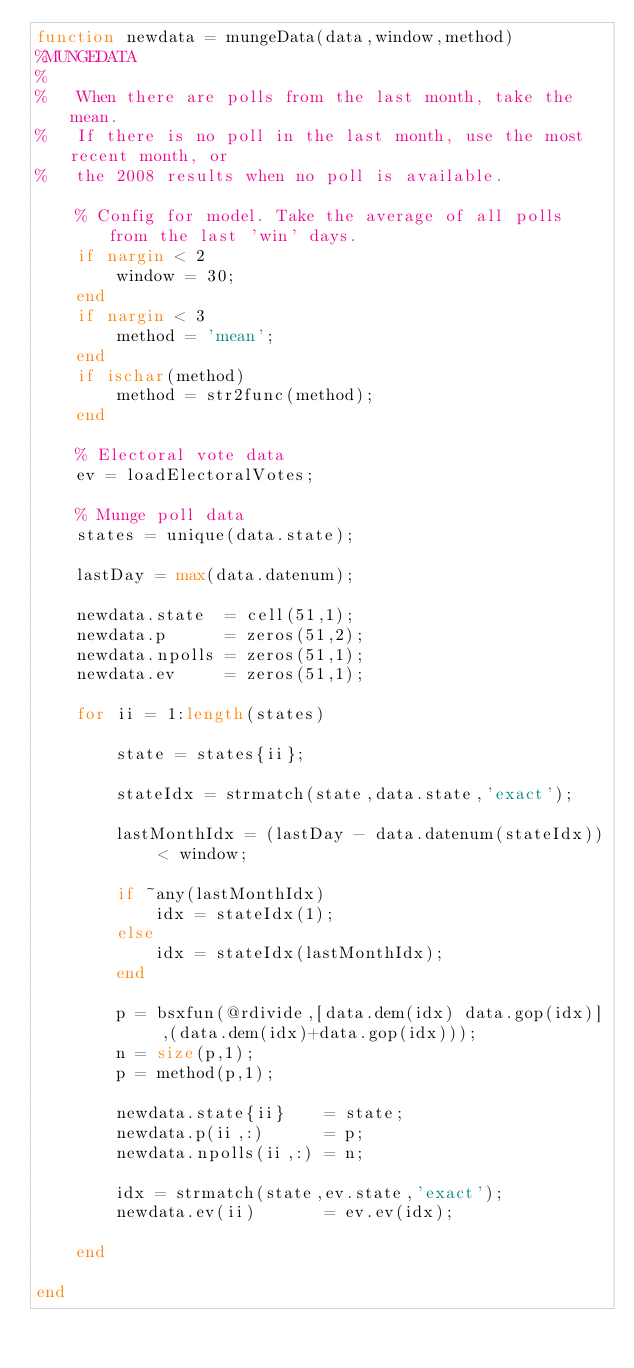<code> <loc_0><loc_0><loc_500><loc_500><_Matlab_>function newdata = mungeData(data,window,method)
%MUNGEDATA
%
%   When there are polls from the last month, take the mean.
%   If there is no poll in the last month, use the most recent month, or
%   the 2008 results when no poll is available.
    
    % Config for model. Take the average of all polls from the last 'win' days.
    if nargin < 2
        window = 30;
    end
    if nargin < 3
        method = 'mean';
    end
    if ischar(method)
        method = str2func(method);
    end
    
    % Electoral vote data
    ev = loadElectoralVotes;
    
    % Munge poll data
    states = unique(data.state);
    
    lastDay = max(data.datenum);
    
    newdata.state  = cell(51,1);
    newdata.p      = zeros(51,2);
    newdata.npolls = zeros(51,1);
    newdata.ev     = zeros(51,1);

    for ii = 1:length(states)
       
        state = states{ii};
        
        stateIdx = strmatch(state,data.state,'exact');
        
        lastMonthIdx = (lastDay - data.datenum(stateIdx)) < window;
        
        if ~any(lastMonthIdx)
            idx = stateIdx(1);
        else
            idx = stateIdx(lastMonthIdx);
        end
        
        p = bsxfun(@rdivide,[data.dem(idx) data.gop(idx)] ,(data.dem(idx)+data.gop(idx)));
        n = size(p,1);
        p = method(p,1);
        
        newdata.state{ii}    = state;
        newdata.p(ii,:)      = p;
        newdata.npolls(ii,:) = n;
        
        idx = strmatch(state,ev.state,'exact');
        newdata.ev(ii)       = ev.ev(idx);
         
    end

end</code> 